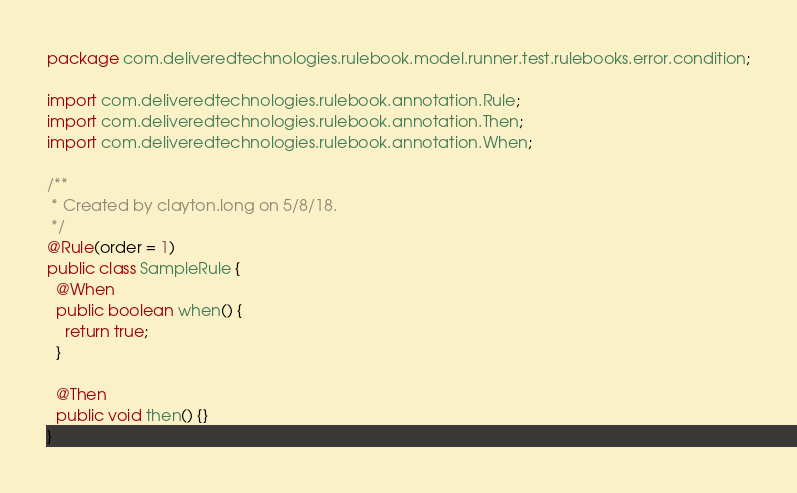<code> <loc_0><loc_0><loc_500><loc_500><_Java_>package com.deliveredtechnologies.rulebook.model.runner.test.rulebooks.error.condition;

import com.deliveredtechnologies.rulebook.annotation.Rule;
import com.deliveredtechnologies.rulebook.annotation.Then;
import com.deliveredtechnologies.rulebook.annotation.When;

/**
 * Created by clayton.long on 5/8/18.
 */
@Rule(order = 1)
public class SampleRule {
  @When
  public boolean when() {
    return true;
  }

  @Then
  public void then() {}
}
</code> 